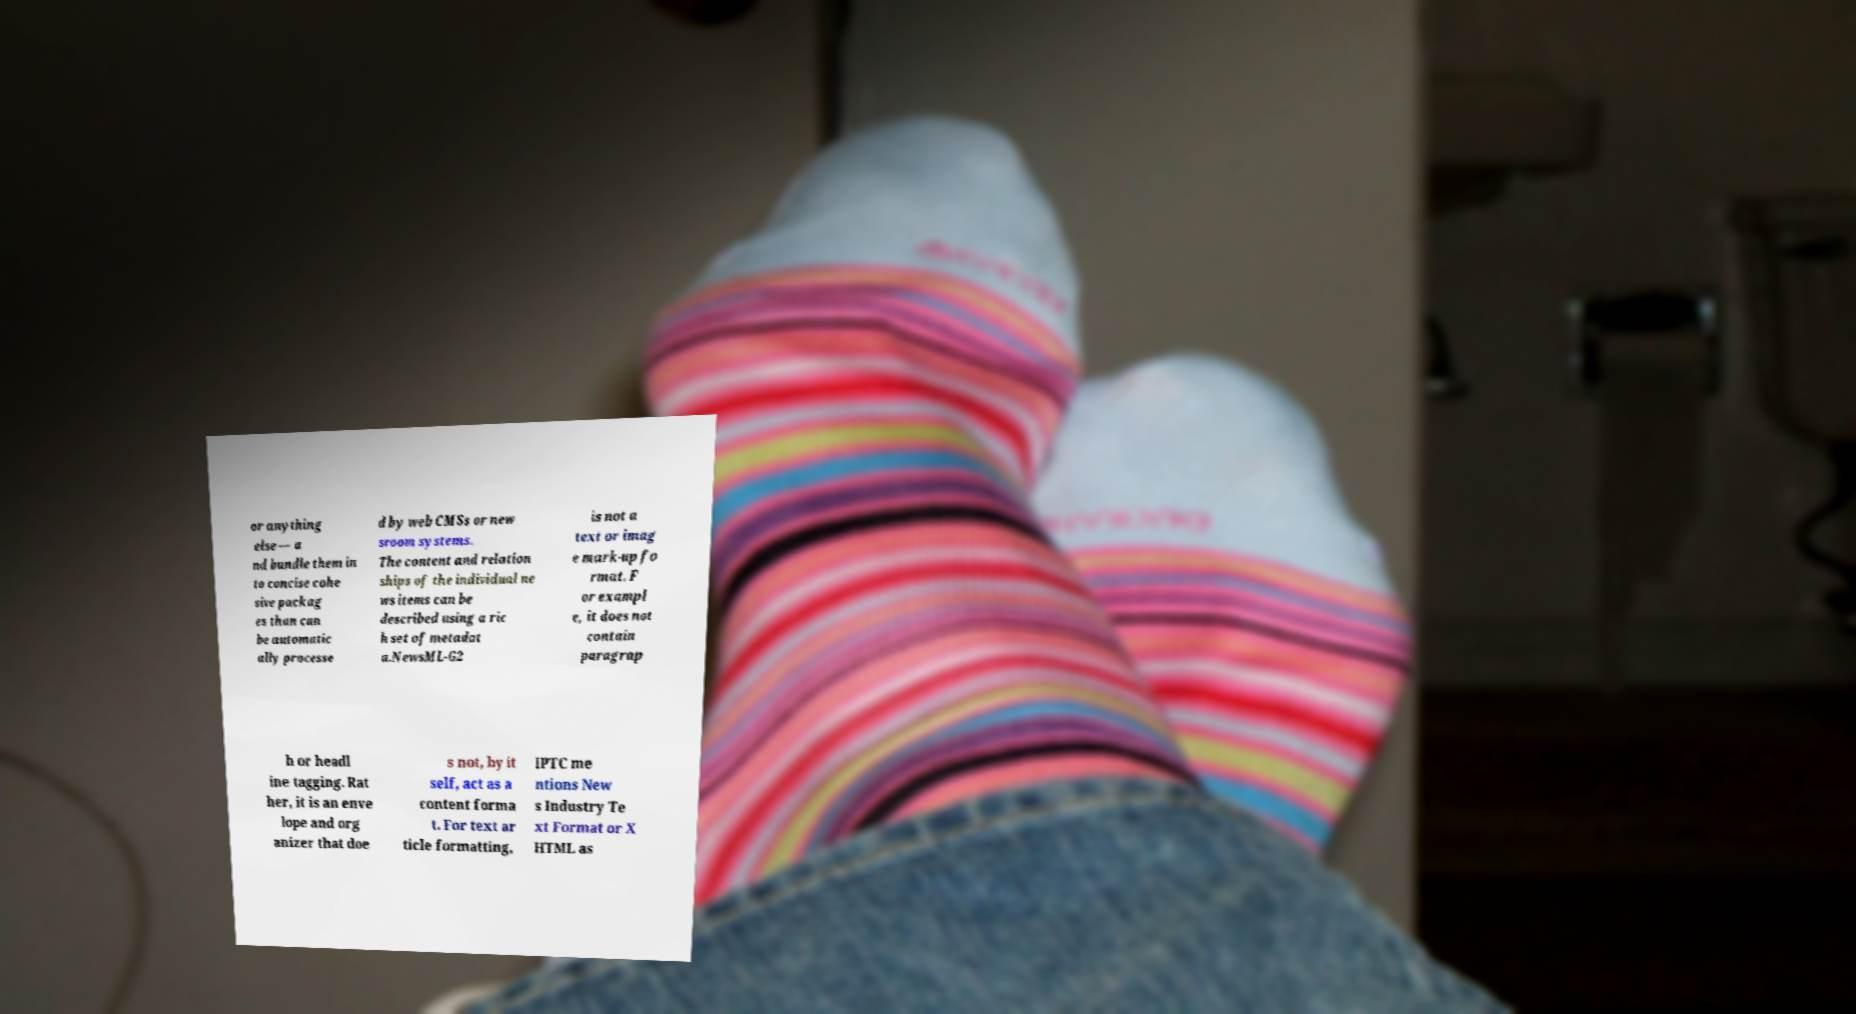There's text embedded in this image that I need extracted. Can you transcribe it verbatim? or anything else — a nd bundle them in to concise cohe sive packag es than can be automatic ally processe d by web CMSs or new sroom systems. The content and relation ships of the individual ne ws items can be described using a ric h set of metadat a.NewsML-G2 is not a text or imag e mark-up fo rmat. F or exampl e, it does not contain paragrap h or headl ine tagging. Rat her, it is an enve lope and org anizer that doe s not, by it self, act as a content forma t. For text ar ticle formatting, IPTC me ntions New s Industry Te xt Format or X HTML as 